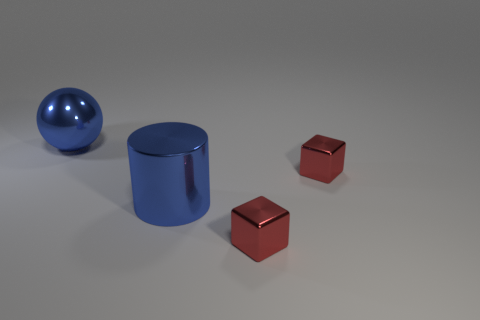What is the shape of the small red object that is on the left side of the small shiny block behind the blue shiny thing that is on the right side of the large metallic sphere?
Your answer should be very brief. Cube. Is the number of small things to the right of the cylinder the same as the number of blue shiny things that are behind the large shiny sphere?
Your response must be concise. No. What color is the metal object that is the same size as the metallic sphere?
Your answer should be compact. Blue. What number of tiny things are either blue shiny balls or cyan balls?
Offer a terse response. 0. The thing that is both behind the big blue metallic cylinder and in front of the blue metallic ball is made of what material?
Offer a very short reply. Metal. Is the shape of the blue object that is right of the metallic sphere the same as the large object to the left of the cylinder?
Provide a short and direct response. No. What is the shape of the large thing that is the same color as the big metallic sphere?
Provide a short and direct response. Cylinder. How many objects are either red metallic cubes behind the big metallic cylinder or tiny purple blocks?
Make the answer very short. 1. Do the cylinder and the metallic sphere have the same size?
Provide a short and direct response. Yes. What color is the large object in front of the ball?
Your answer should be compact. Blue. 